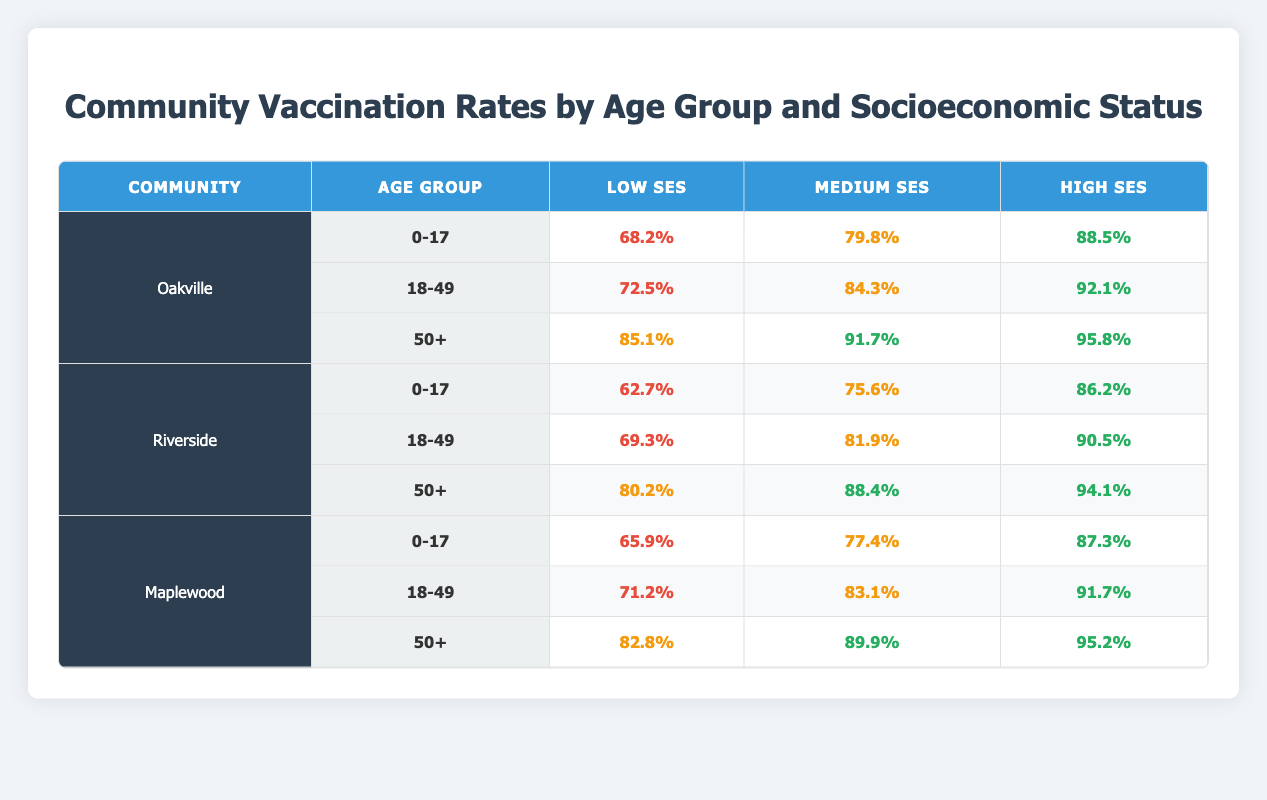What is the vaccination rate for the age group 18-49 in Riverside with low socioeconomic status? The table shows that in Riverside, the vaccination rate for the age group 18-49 under low socioeconomic status is 69.3%.
Answer: 69.3% What is the highest vaccination rate recorded for any age group in Maplewood? The highest vaccination rate in Maplewood is 95.2%, which is for the age group 50+ under high socioeconomic status.
Answer: 95.2% Is the vaccination rate for 0-17 age group in Oakville higher than that in Riverside? In Oakville, the vaccination rate for the 0-17 age group is 68.2%, while in Riverside it is 62.7%. Since 68.2% is greater than 62.7%, the statement is true.
Answer: Yes What is the vaccination rate difference between the 50+ age group and the 0-17 age group in Oakville with medium socioeconomic status? For Oakville, the vaccination rate for the 50+ age group is 91.7% and for the 0-17 age group it is 79.8%. The difference is calculated as 91.7% - 79.8% = 11.9%.
Answer: 11.9% What is the average vaccination rate for the age group 18-49 across all socioeconomic statuses in Oakville? The vaccination rates for age group 18-49 in Oakville are 72.5% (low), 84.3% (medium), and 92.1% (high). The average is (72.5 + 84.3 + 92.1) / 3 = 82.3%.
Answer: 82.3% Does any community have a lower vaccination rate for the 50+ age group than Riverside's low socioeconomic status? Riverside's low socioeconomic status vaccination rate for the 50+ age group is 80.2%. In Oakville, it is 85.1% (higher), and in Maplewood it is 82.8% (higher). Therefore, the statement is false as no community has a lower rate.
Answer: No What is the total vaccination rate for all age groups in Maplewood under high socioeconomic status? The vaccination rates for high socioeconomic status in Maplewood are 87.3% (0-17), 91.7% (18-49), and 95.2% (50+). The total is the sum of these rates: 87.3 + 91.7 + 95.2 = 274.2%.
Answer: 274.2% Which community shows the greatest improvements in vaccination rates from low to high socioeconomic status in the age group 0-17? The vaccination rates for 0-17 in Oakville are 68.2% (low), 79.8% (medium), and 88.5% (high, change of 20.3%). In Riverside, they are 62.7% (low), 75.6% (medium), and 86.2% (high, change of 23.5%). For Maplewood, they are 65.9% (low), 77.4% (medium), and 87.3% (high, change of 21.4%). Riverside shows the greatest improvement of 23.5%.
Answer: Riverside 